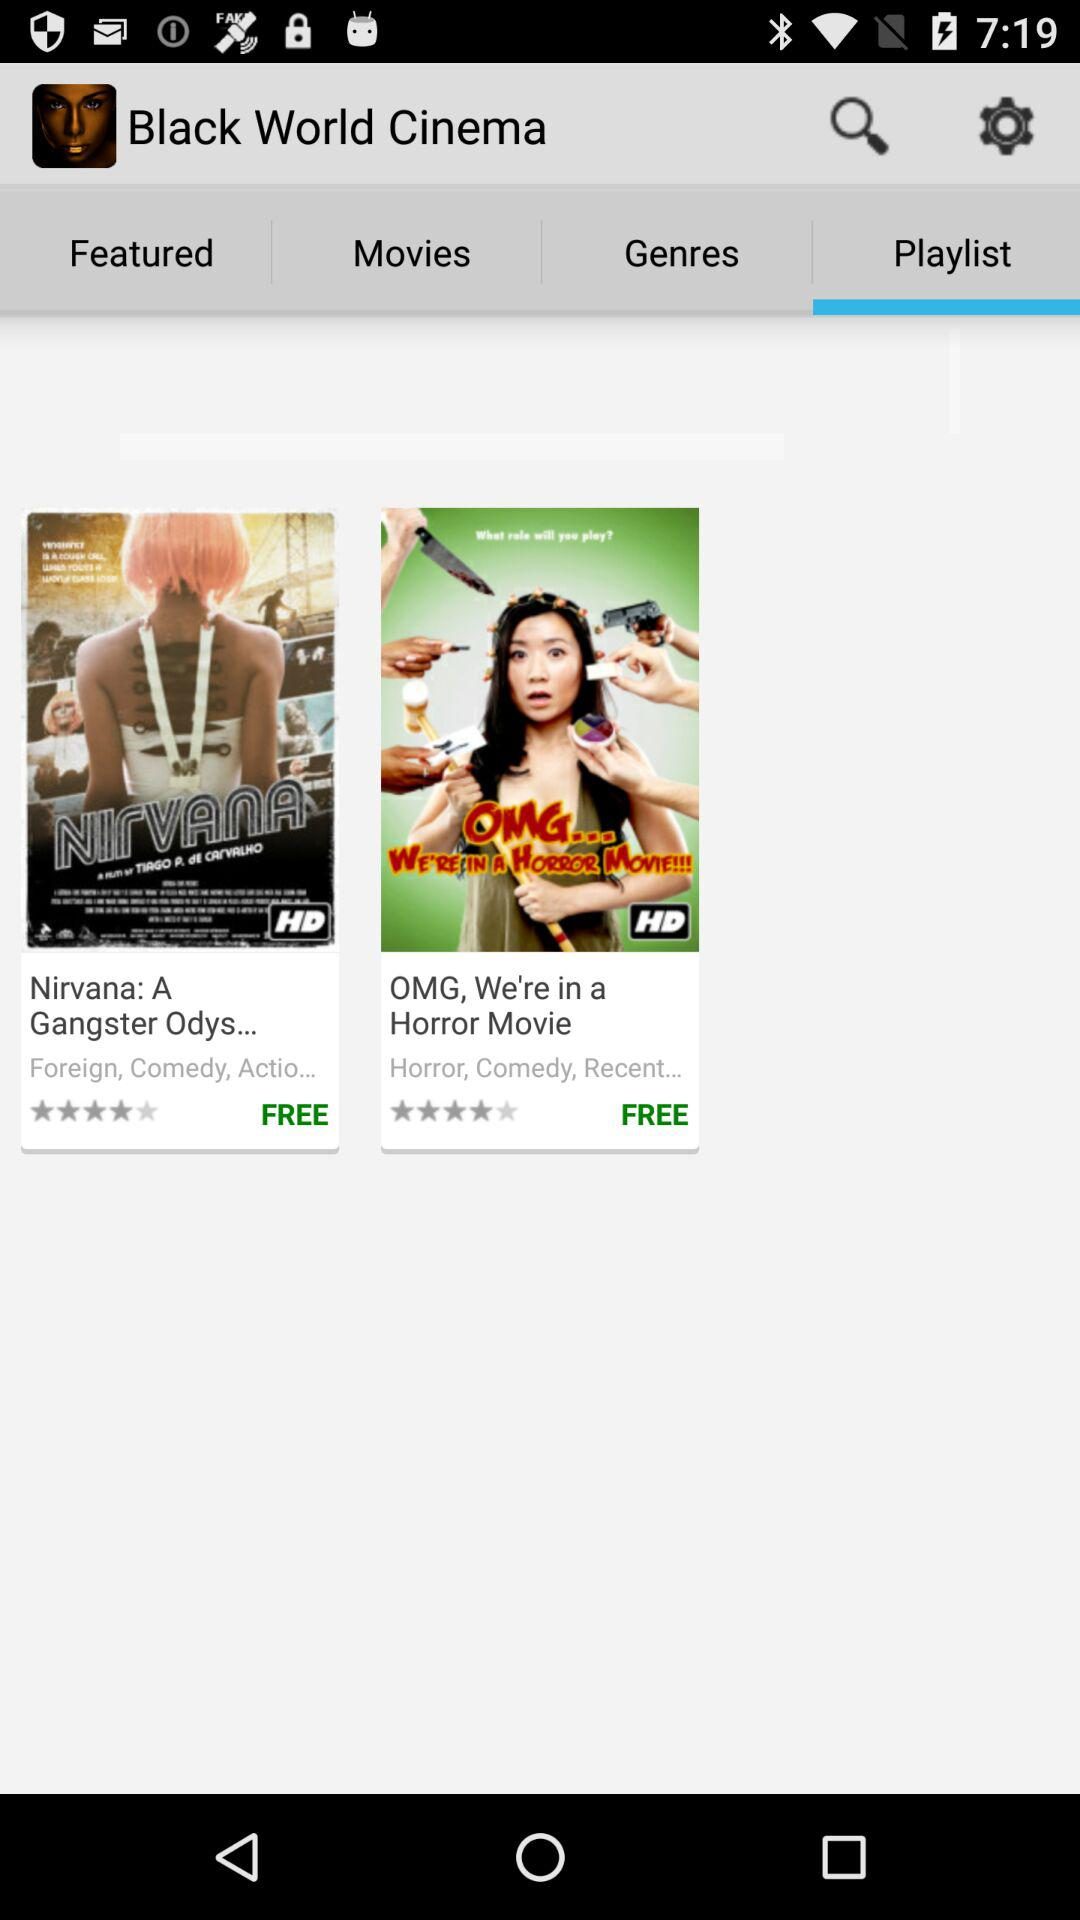What movies are there in the Playlist? The movies are "Nirvana: A Gangster Odys..." and "OMG, We're in a Horror Movie". 